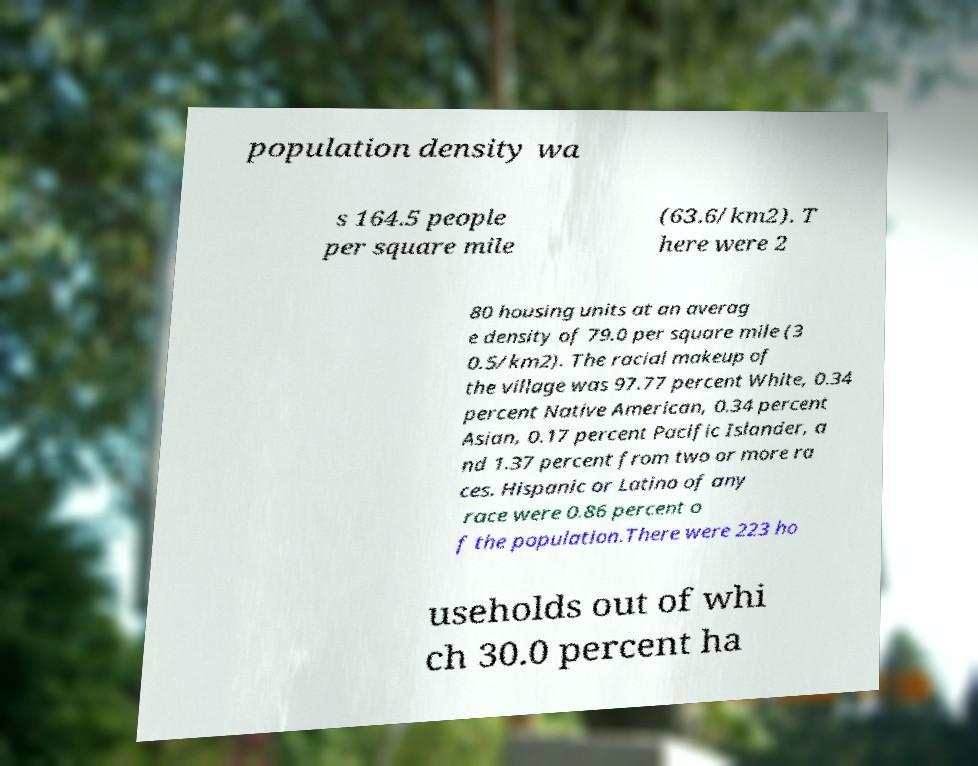There's text embedded in this image that I need extracted. Can you transcribe it verbatim? population density wa s 164.5 people per square mile (63.6/km2). T here were 2 80 housing units at an averag e density of 79.0 per square mile (3 0.5/km2). The racial makeup of the village was 97.77 percent White, 0.34 percent Native American, 0.34 percent Asian, 0.17 percent Pacific Islander, a nd 1.37 percent from two or more ra ces. Hispanic or Latino of any race were 0.86 percent o f the population.There were 223 ho useholds out of whi ch 30.0 percent ha 